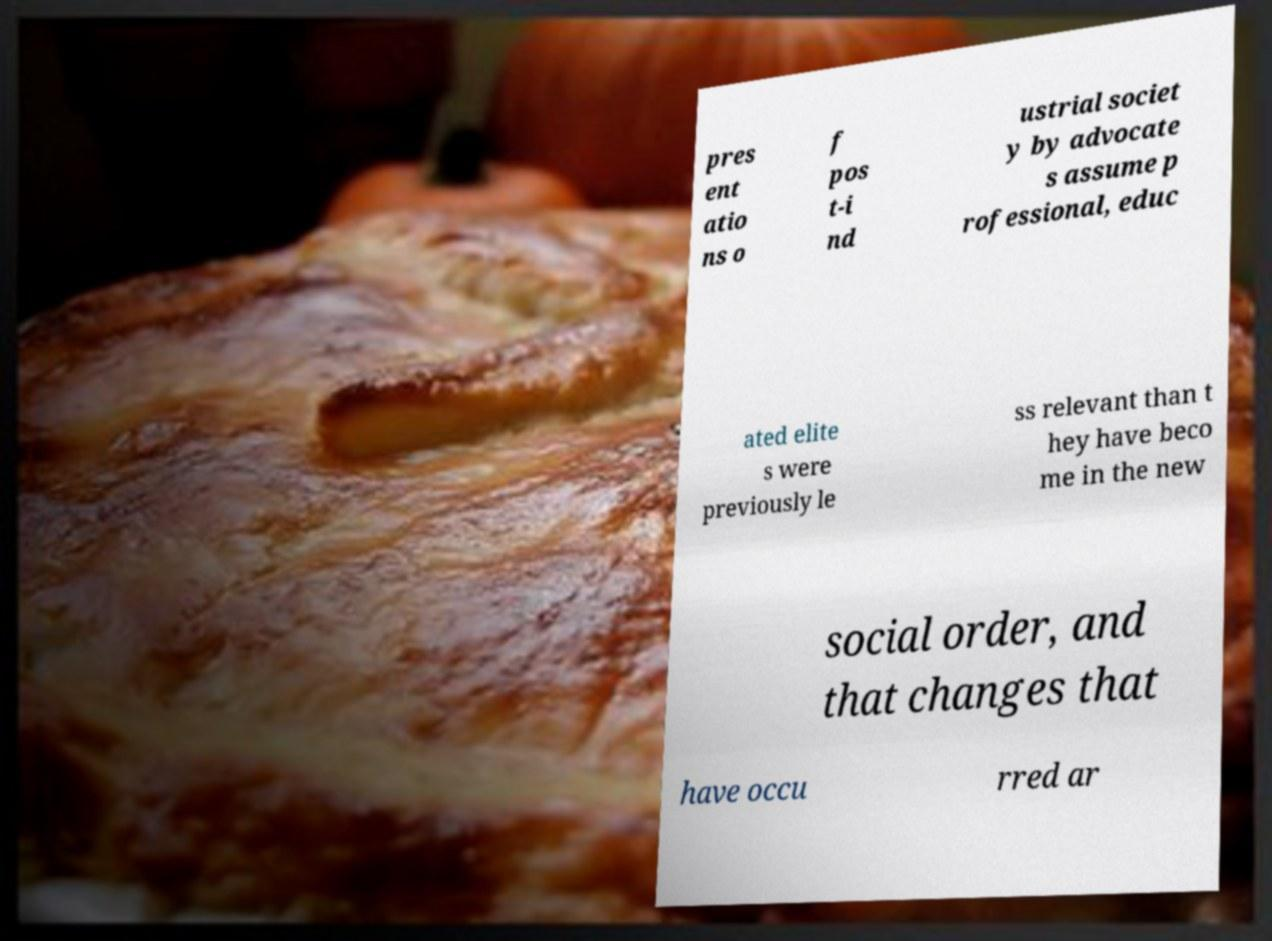There's text embedded in this image that I need extracted. Can you transcribe it verbatim? pres ent atio ns o f pos t-i nd ustrial societ y by advocate s assume p rofessional, educ ated elite s were previously le ss relevant than t hey have beco me in the new social order, and that changes that have occu rred ar 